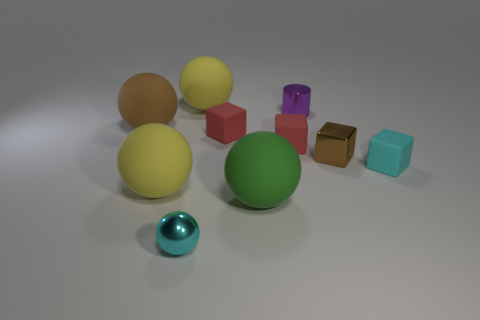How many objects are either gray rubber objects or yellow things?
Your answer should be compact. 2. The green thing that is the same shape as the large brown object is what size?
Give a very brief answer. Large. What size is the brown rubber ball?
Your answer should be very brief. Large. Are there more brown matte spheres in front of the cyan metal thing than metallic things?
Your response must be concise. No. Is there anything else that is the same material as the tiny cyan block?
Offer a very short reply. Yes. There is a block to the right of the tiny brown shiny object; is its color the same as the matte block that is left of the green rubber ball?
Your response must be concise. No. What material is the cyan thing behind the big yellow thing left of the small cyan thing that is left of the big green sphere?
Provide a succinct answer. Rubber. Is the number of brown metallic objects greater than the number of purple rubber cubes?
Offer a very short reply. Yes. Are there any other things that are the same color as the metal cylinder?
Your answer should be very brief. No. What size is the brown object that is the same material as the small purple object?
Keep it short and to the point. Small. 